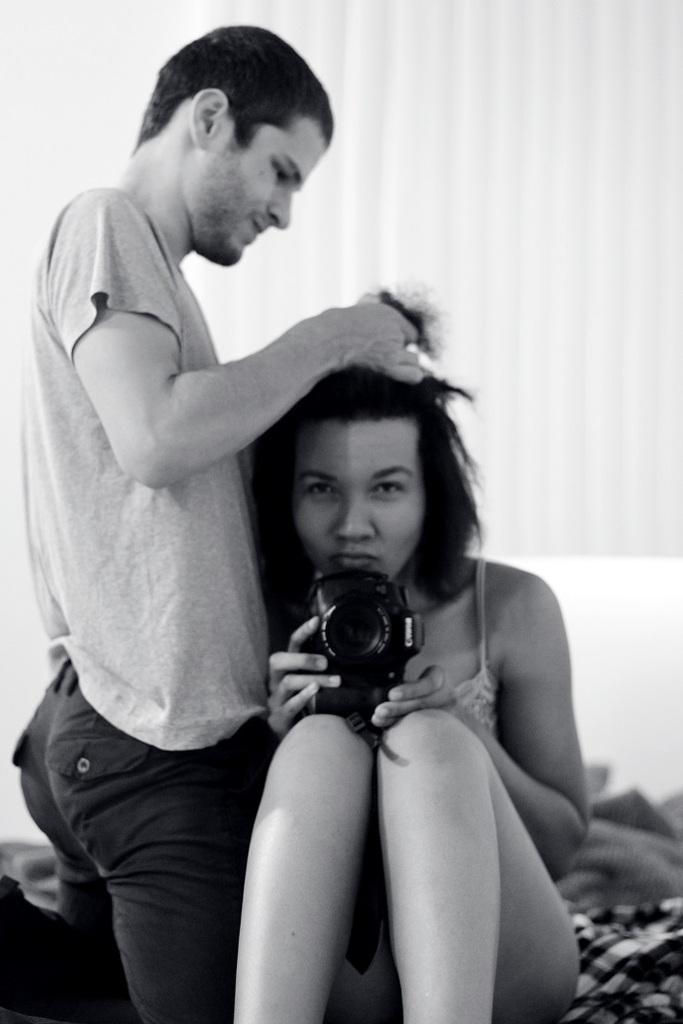How many people are in the image? There are two people in the image. What is one person doing in the image? One person is holding a camera. Are there any dinosaurs visible in the image? No, there are no dinosaurs present in the image. Is anyone wearing a scarf in the image? The facts provided do not mention any scarves, so it cannot be determined if anyone is wearing one in the image. 